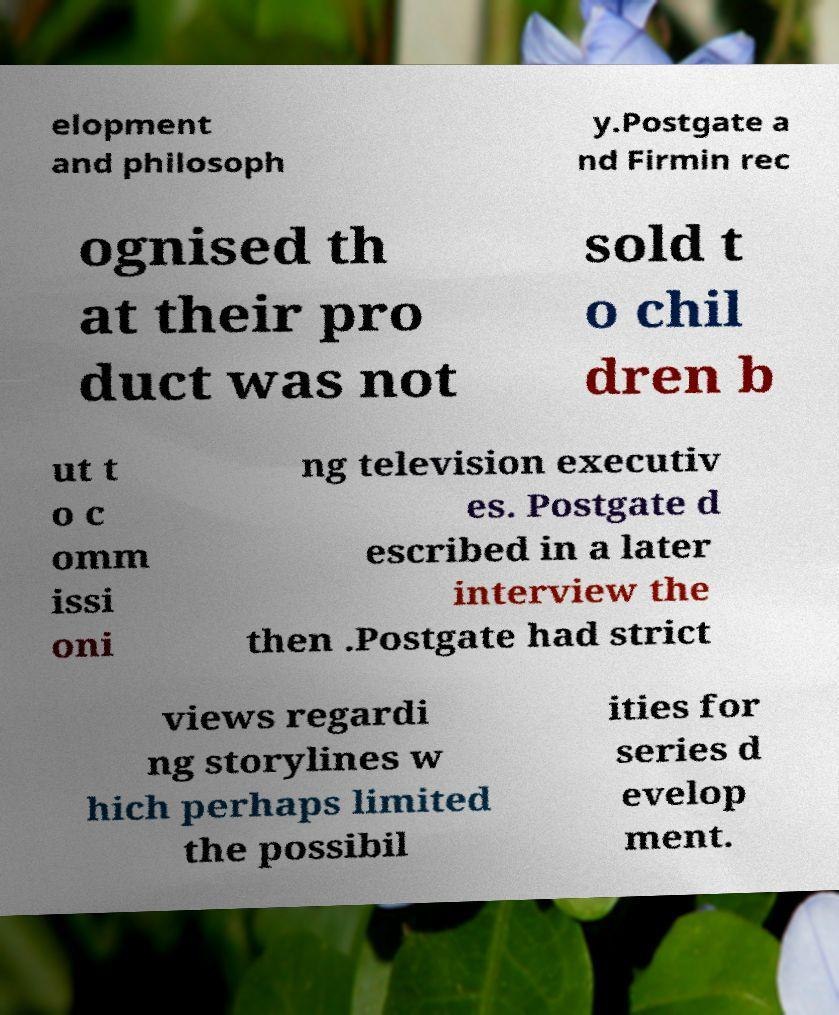For documentation purposes, I need the text within this image transcribed. Could you provide that? elopment and philosoph y.Postgate a nd Firmin rec ognised th at their pro duct was not sold t o chil dren b ut t o c omm issi oni ng television executiv es. Postgate d escribed in a later interview the then .Postgate had strict views regardi ng storylines w hich perhaps limited the possibil ities for series d evelop ment. 